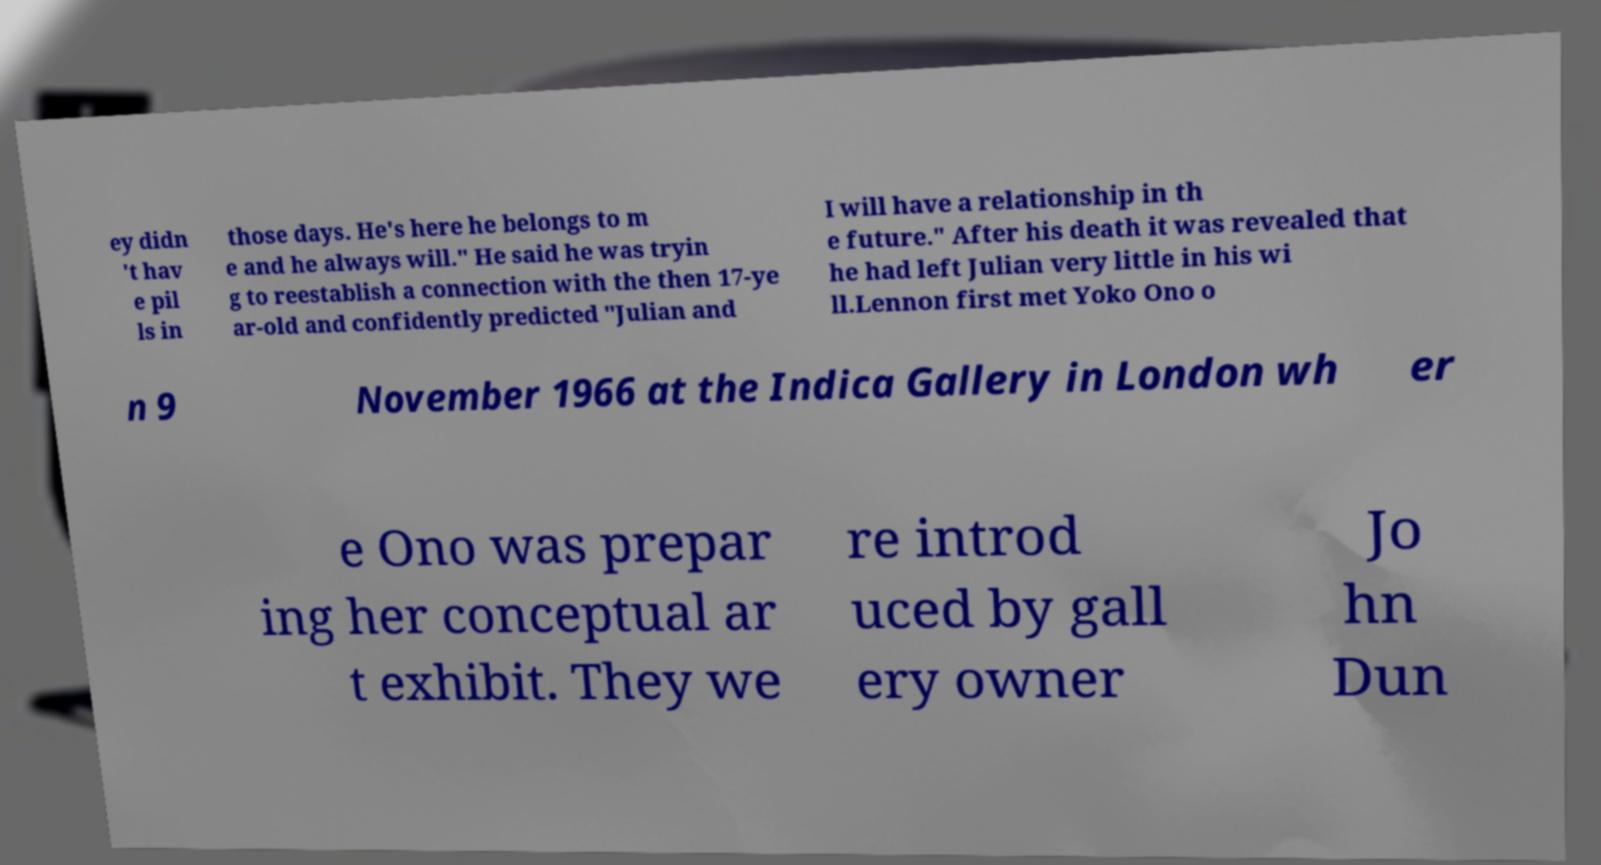Can you read and provide the text displayed in the image?This photo seems to have some interesting text. Can you extract and type it out for me? ey didn 't hav e pil ls in those days. He's here he belongs to m e and he always will." He said he was tryin g to reestablish a connection with the then 17-ye ar-old and confidently predicted "Julian and I will have a relationship in th e future." After his death it was revealed that he had left Julian very little in his wi ll.Lennon first met Yoko Ono o n 9 November 1966 at the Indica Gallery in London wh er e Ono was prepar ing her conceptual ar t exhibit. They we re introd uced by gall ery owner Jo hn Dun 